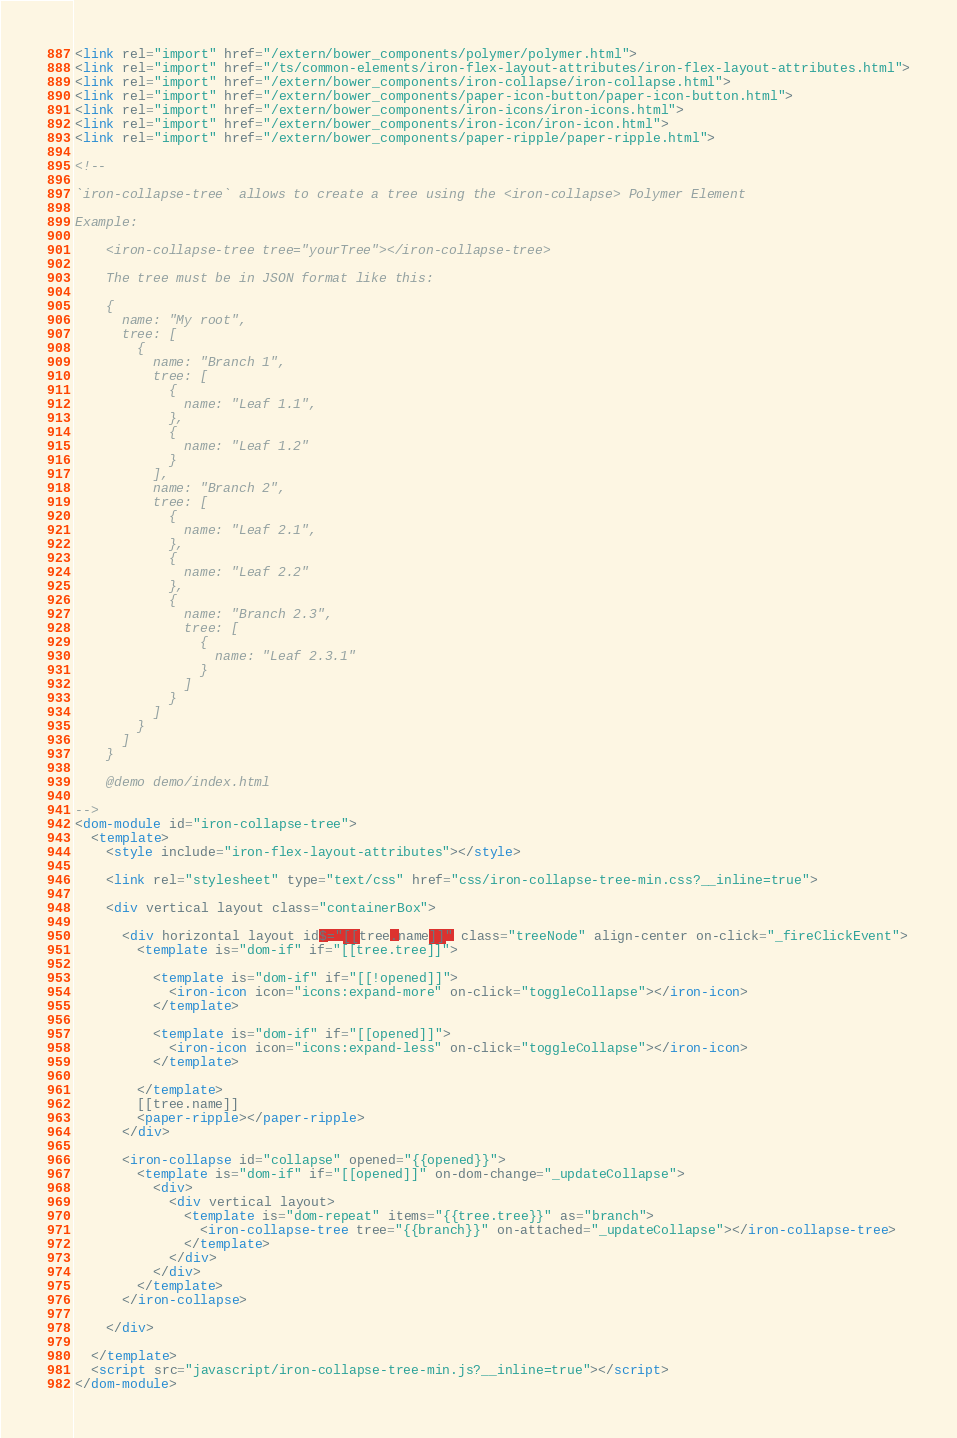Convert code to text. <code><loc_0><loc_0><loc_500><loc_500><_HTML_><link rel="import" href="/extern/bower_components/polymer/polymer.html">
<link rel="import" href="/ts/common-elements/iron-flex-layout-attributes/iron-flex-layout-attributes.html">
<link rel="import" href="/extern/bower_components/iron-collapse/iron-collapse.html">
<link rel="import" href="/extern/bower_components/paper-icon-button/paper-icon-button.html">
<link rel="import" href="/extern/bower_components/iron-icons/iron-icons.html">
<link rel="import" href="/extern/bower_components/iron-icon/iron-icon.html">
<link rel="import" href="/extern/bower_components/paper-ripple/paper-ripple.html">

<!--

`iron-collapse-tree` allows to create a tree using the <iron-collapse> Polymer Element

Example:

    <iron-collapse-tree tree="yourTree"></iron-collapse-tree>
    
    The tree must be in JSON format like this:
    
    {
      name: "My root",
      tree: [
        {
          name: "Branch 1",
          tree: [
            {
              name: "Leaf 1.1",
            },
            {
              name: "Leaf 1.2"
            }
          ],
          name: "Branch 2",
          tree: [
            {
              name: "Leaf 2.1",
            },
            {
              name: "Leaf 2.2"
            },
            {
              name: "Branch 2.3",
              tree: [
                {
                  name: "Leaf 2.3.1"
                }
              ]
            }
          ]
        }
      ]
    }
    
    @demo demo/index.html

-->
<dom-module id="iron-collapse-tree">
  <template>
    <style include="iron-flex-layout-attributes"></style>

    <link rel="stylesheet" type="text/css" href="css/iron-collapse-tree-min.css?__inline=true">

    <div vertical layout class="containerBox">

      <div horizontal layout id$="[[tree.name]]" class="treeNode" align-center on-click="_fireClickEvent">
        <template is="dom-if" if="[[tree.tree]]">
          
          <template is="dom-if" if="[[!opened]]">
            <iron-icon icon="icons:expand-more" on-click="toggleCollapse"></iron-icon>
          </template>
          
          <template is="dom-if" if="[[opened]]">
            <iron-icon icon="icons:expand-less" on-click="toggleCollapse"></iron-icon>
          </template>
        
        </template>
        [[tree.name]]
        <paper-ripple></paper-ripple>
      </div>
      
      <iron-collapse id="collapse" opened="{{opened}}">
        <template is="dom-if" if="[[opened]]" on-dom-change="_updateCollapse">
          <div>
            <div vertical layout>
              <template is="dom-repeat" items="{{tree.tree}}" as="branch">
                <iron-collapse-tree tree="{{branch}}" on-attached="_updateCollapse"></iron-collapse-tree>
              </template>
            </div>
          </div>
        </template>
      </iron-collapse>
      
    </div>

  </template>
  <script src="javascript/iron-collapse-tree-min.js?__inline=true"></script>
</dom-module>
</code> 